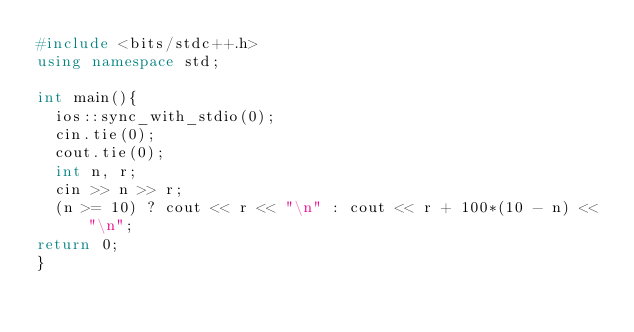<code> <loc_0><loc_0><loc_500><loc_500><_C++_>#include <bits/stdc++.h>
using namespace std;

int main(){
  ios::sync_with_stdio(0);
  cin.tie(0);
  cout.tie(0);
  int n, r;
  cin >> n >> r;
  (n >= 10) ? cout << r << "\n" : cout << r + 100*(10 - n) << "\n";
return 0;
}
</code> 